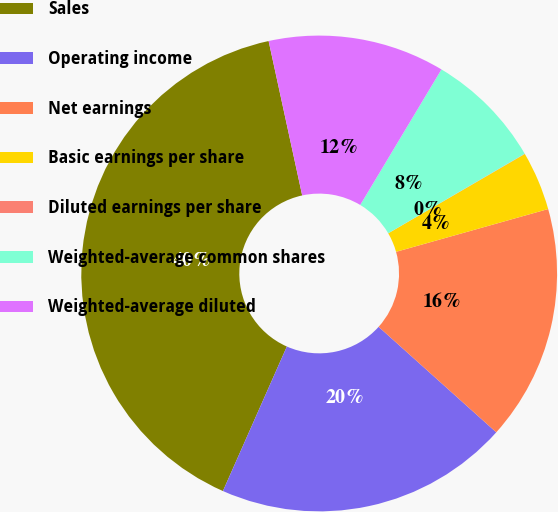<chart> <loc_0><loc_0><loc_500><loc_500><pie_chart><fcel>Sales<fcel>Operating income<fcel>Net earnings<fcel>Basic earnings per share<fcel>Diluted earnings per share<fcel>Weighted-average common shares<fcel>Weighted-average diluted<nl><fcel>39.96%<fcel>19.99%<fcel>16.0%<fcel>4.01%<fcel>0.02%<fcel>8.01%<fcel>12.0%<nl></chart> 